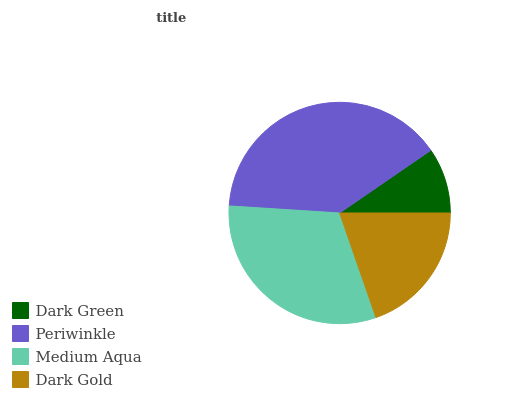Is Dark Green the minimum?
Answer yes or no. Yes. Is Periwinkle the maximum?
Answer yes or no. Yes. Is Medium Aqua the minimum?
Answer yes or no. No. Is Medium Aqua the maximum?
Answer yes or no. No. Is Periwinkle greater than Medium Aqua?
Answer yes or no. Yes. Is Medium Aqua less than Periwinkle?
Answer yes or no. Yes. Is Medium Aqua greater than Periwinkle?
Answer yes or no. No. Is Periwinkle less than Medium Aqua?
Answer yes or no. No. Is Medium Aqua the high median?
Answer yes or no. Yes. Is Dark Gold the low median?
Answer yes or no. Yes. Is Periwinkle the high median?
Answer yes or no. No. Is Medium Aqua the low median?
Answer yes or no. No. 